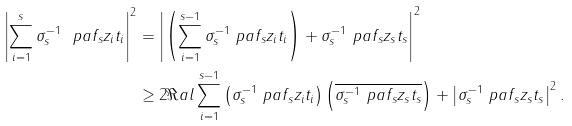Convert formula to latex. <formula><loc_0><loc_0><loc_500><loc_500>\left | \sum _ { i = 1 } ^ { s } \sigma _ { s } ^ { - 1 } \ p a { f _ { s } } { z _ { i } } t _ { i } \right | ^ { 2 } & = \left | \left ( \sum _ { i = 1 } ^ { s - 1 } \sigma _ { s } ^ { - 1 } \ p a { f _ { s } } { z _ { i } } t _ { i } \right ) + \sigma _ { s } ^ { - 1 } \ p a { f _ { s } } { z _ { s } } t _ { s } \right | ^ { 2 } \\ & \geq 2 \Re a l \sum _ { i = 1 } ^ { s - 1 } \left ( \sigma _ { s } ^ { - 1 } \ p a { f _ { s } } { z _ { i } } t _ { i } \right ) \left ( \overline { \sigma _ { s } ^ { - 1 } \ p a { f _ { s } } { z _ { s } } t _ { s } } \right ) + \left | \sigma _ { s } ^ { - 1 } \ p a { f _ { s } } { z _ { s } } t _ { s } \right | ^ { 2 } .</formula> 